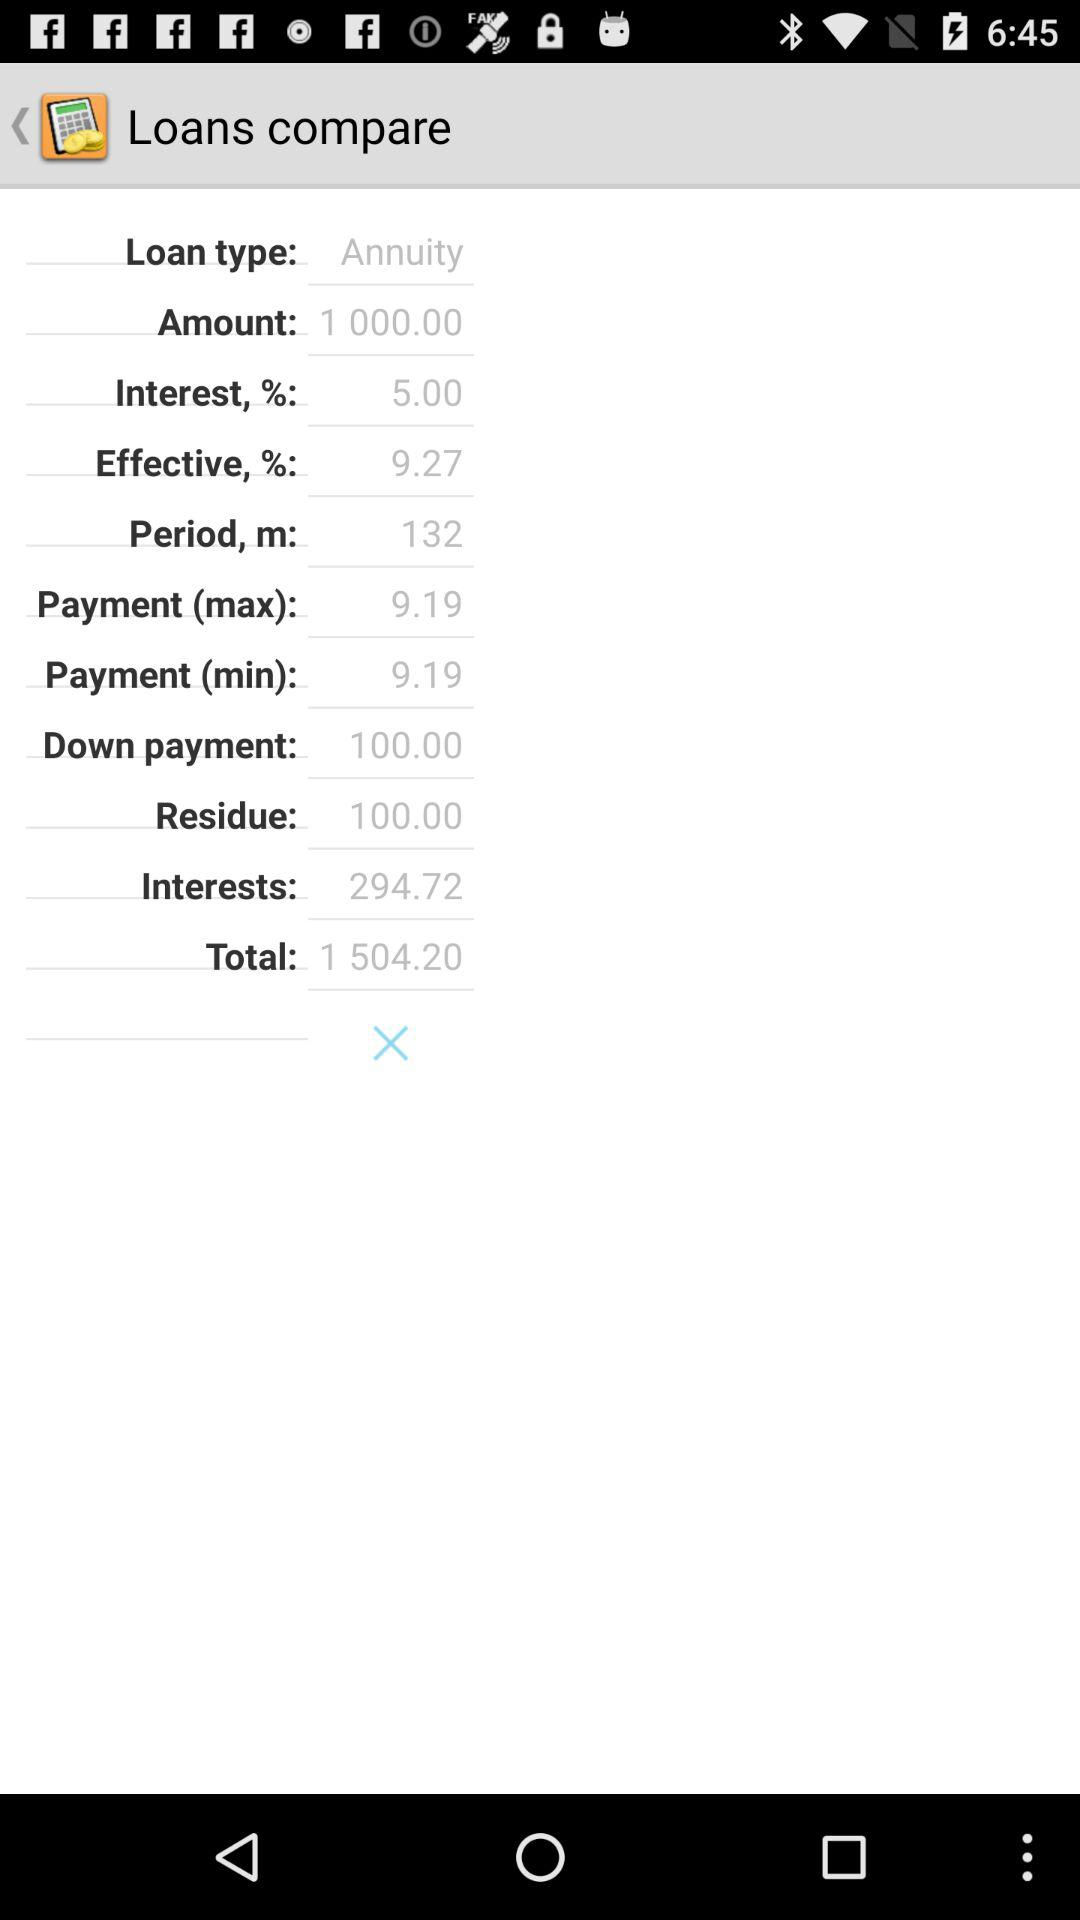What is the loan type? The loan type is "Annuity". 